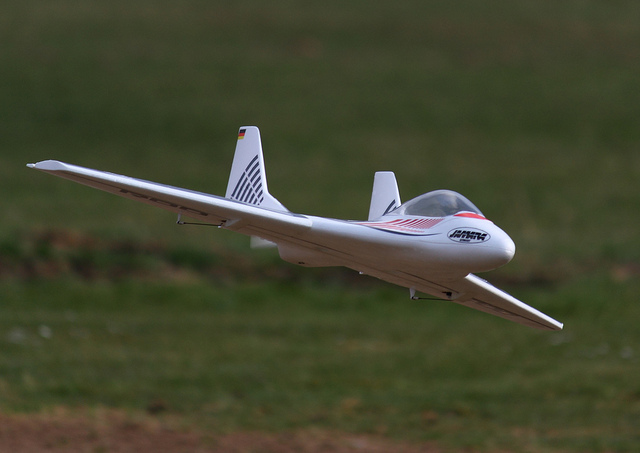<image>How many people in the plane? It is unclear how many people are in the plane. It might be 0 or 1. How many people in the plane? I don't know how many people are in the plane. It can be either 1 or 0. 